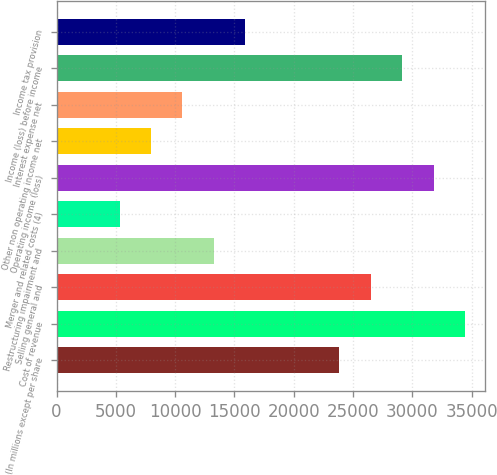<chart> <loc_0><loc_0><loc_500><loc_500><bar_chart><fcel>(In millions except per share<fcel>Cost of revenue<fcel>Selling general and<fcel>Restructuring impairment and<fcel>Merger and related costs (4)<fcel>Operating income (loss)<fcel>Other non operating income net<fcel>Interest expense net<fcel>Income (loss) before income<fcel>Income tax provision<nl><fcel>23847.6<fcel>34441.2<fcel>26496<fcel>13254<fcel>5308.8<fcel>31792.8<fcel>7957.2<fcel>10605.6<fcel>29144.4<fcel>15902.4<nl></chart> 